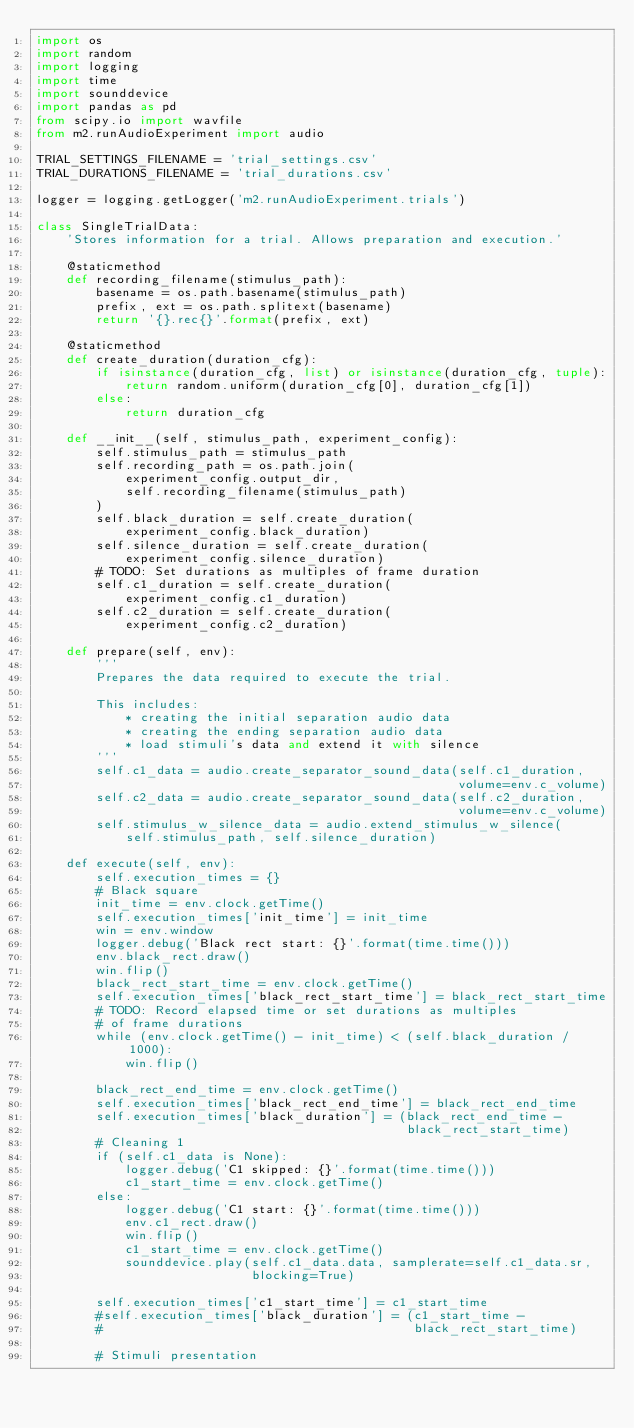<code> <loc_0><loc_0><loc_500><loc_500><_Python_>import os
import random
import logging
import time
import sounddevice
import pandas as pd
from scipy.io import wavfile
from m2.runAudioExperiment import audio

TRIAL_SETTINGS_FILENAME = 'trial_settings.csv'
TRIAL_DURATIONS_FILENAME = 'trial_durations.csv'

logger = logging.getLogger('m2.runAudioExperiment.trials')

class SingleTrialData:
    'Stores information for a trial. Allows preparation and execution.'

    @staticmethod
    def recording_filename(stimulus_path):
        basename = os.path.basename(stimulus_path)
        prefix, ext = os.path.splitext(basename) 
        return '{}.rec{}'.format(prefix, ext)

    @staticmethod
    def create_duration(duration_cfg):
        if isinstance(duration_cfg, list) or isinstance(duration_cfg, tuple):
            return random.uniform(duration_cfg[0], duration_cfg[1])
        else:
            return duration_cfg

    def __init__(self, stimulus_path, experiment_config):
        self.stimulus_path = stimulus_path
        self.recording_path = os.path.join(
            experiment_config.output_dir,
            self.recording_filename(stimulus_path)
        )
        self.black_duration = self.create_duration(
            experiment_config.black_duration)
        self.silence_duration = self.create_duration(
            experiment_config.silence_duration)
        # TODO: Set durations as multiples of frame duration
        self.c1_duration = self.create_duration(
            experiment_config.c1_duration)
        self.c2_duration = self.create_duration(
            experiment_config.c2_duration)

    def prepare(self, env):
        '''
        Prepares the data required to execute the trial.

        This includes:
            * creating the initial separation audio data
            * creating the ending separation audio data
            * load stimuli's data and extend it with silence 
        '''
        self.c1_data = audio.create_separator_sound_data(self.c1_duration,
                                                         volume=env.c_volume)
        self.c2_data = audio.create_separator_sound_data(self.c2_duration,
                                                         volume=env.c_volume)
        self.stimulus_w_silence_data = audio.extend_stimulus_w_silence(
            self.stimulus_path, self.silence_duration)

    def execute(self, env):
        self.execution_times = {}
        # Black square 
        init_time = env.clock.getTime()
        self.execution_times['init_time'] = init_time
        win = env.window
        logger.debug('Black rect start: {}'.format(time.time()))
        env.black_rect.draw()
        win.flip()
        black_rect_start_time = env.clock.getTime()
        self.execution_times['black_rect_start_time'] = black_rect_start_time
        # TODO: Record elapsed time or set durations as multiples
        # of frame durations
        while (env.clock.getTime() - init_time) < (self.black_duration / 1000):
            win.flip()

        black_rect_end_time = env.clock.getTime()
        self.execution_times['black_rect_end_time'] = black_rect_end_time
        self.execution_times['black_duration'] = (black_rect_end_time -
                                                  black_rect_start_time)
        # Cleaning 1
        if (self.c1_data is None):
            logger.debug('C1 skipped: {}'.format(time.time()))
            c1_start_time = env.clock.getTime()
        else:
            logger.debug('C1 start: {}'.format(time.time()))
            env.c1_rect.draw()
            win.flip()
            c1_start_time = env.clock.getTime()
            sounddevice.play(self.c1_data.data, samplerate=self.c1_data.sr,
                             blocking=True)
        
        self.execution_times['c1_start_time'] = c1_start_time
        #self.execution_times['black_duration'] = (c1_start_time -
        #                                          black_rect_start_time)
        
        # Stimuli presentation</code> 